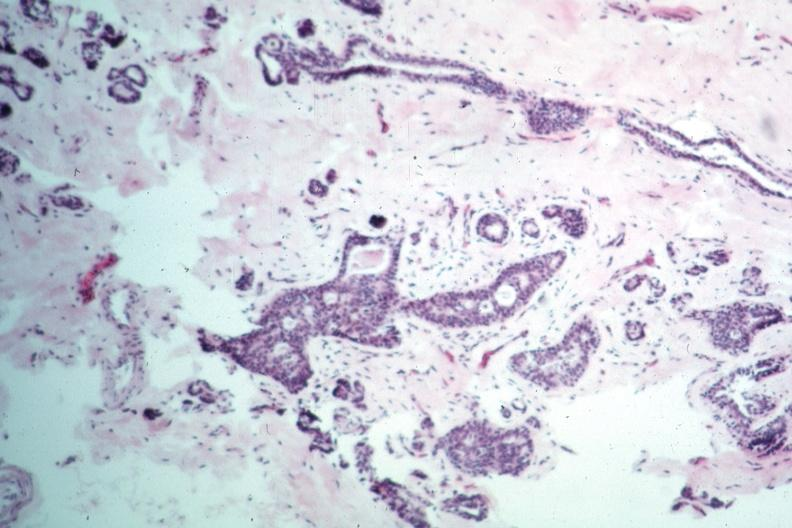where is this area in the body?
Answer the question using a single word or phrase. Breast 